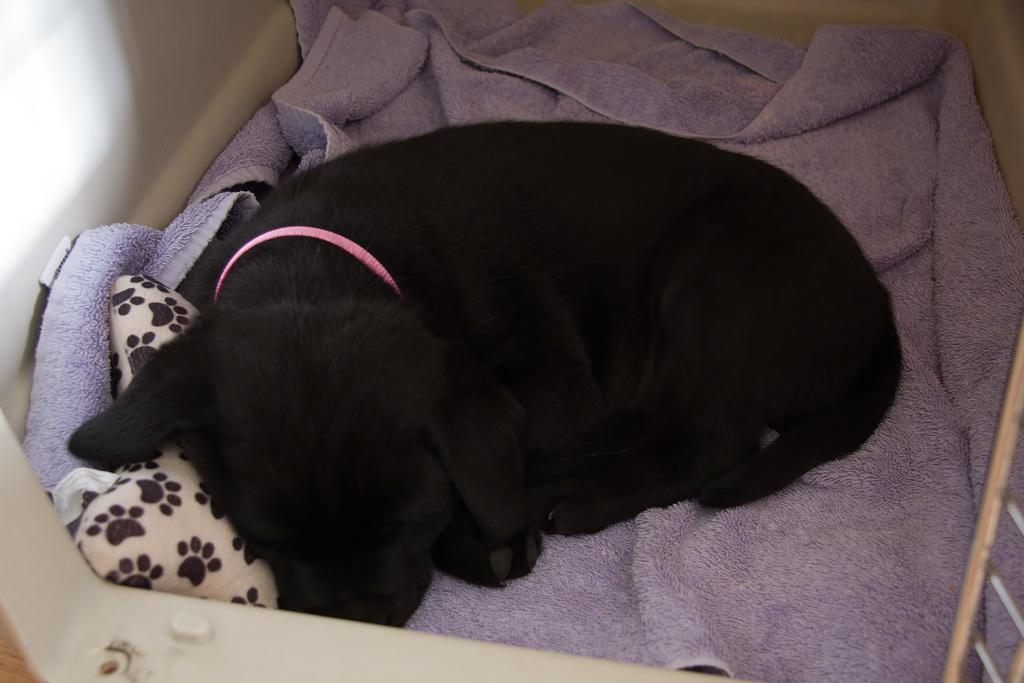Describe this image in one or two sentences. In this image we can see a black color dog on a cloth. To the left side of the image there is wall. 